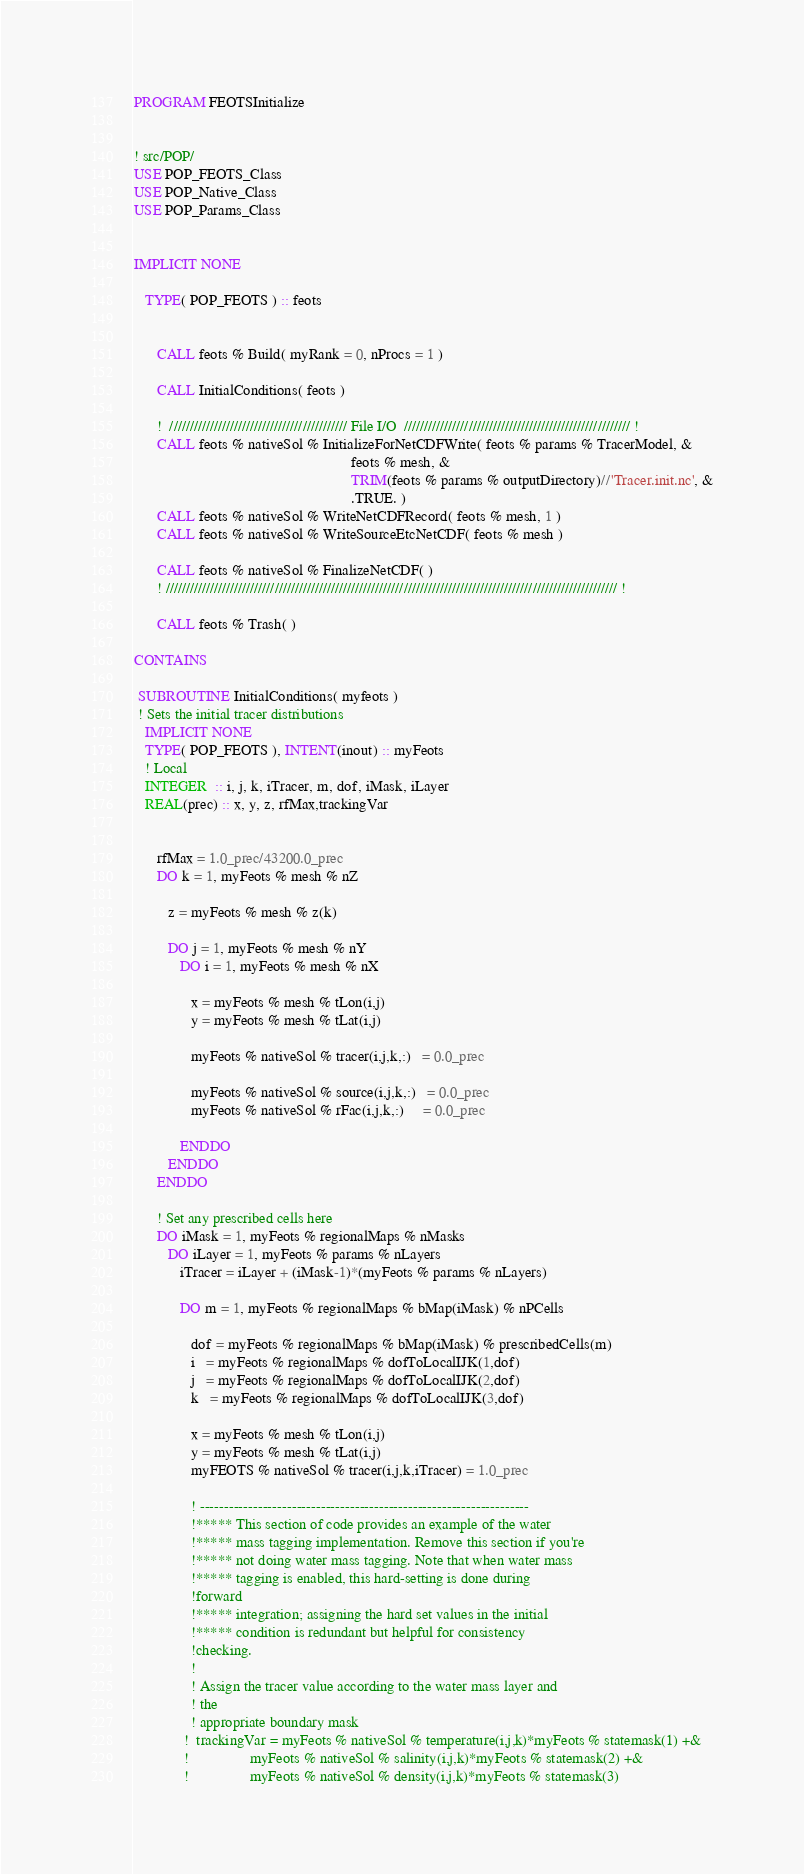<code> <loc_0><loc_0><loc_500><loc_500><_FORTRAN_>PROGRAM FEOTSInitialize


! src/POP/
USE POP_FEOTS_Class
USE POP_Native_Class
USE POP_Params_Class


IMPLICIT NONE

   TYPE( POP_FEOTS ) :: feots


      CALL feots % Build( myRank = 0, nProcs = 1 )

      CALL InitialConditions( feots )

      !  //////////////////////////////////////////// File I/O  //////////////////////////////////////////////////////// !
      CALL feots % nativeSol % InitializeForNetCDFWrite( feots % params % TracerModel, &
                                                         feots % mesh, &
                                                         TRIM(feots % params % outputDirectory)//'Tracer.init.nc', &
                                                         .TRUE. )
      CALL feots % nativeSol % WriteNetCDFRecord( feots % mesh, 1 )
      CALL feots % nativeSol % WriteSourceEtcNetCDF( feots % mesh )

      CALL feots % nativeSol % FinalizeNetCDF( )
      ! //////////////////////////////////////////////////////////////////////////////////////////////////////////////// !

      CALL feots % Trash( )

CONTAINS

 SUBROUTINE InitialConditions( myfeots )
 ! Sets the initial tracer distributions
   IMPLICIT NONE
   TYPE( POP_FEOTS ), INTENT(inout) :: myFeots
   ! Local
   INTEGER  :: i, j, k, iTracer, m, dof, iMask, iLayer
   REAL(prec) :: x, y, z, rfMax,trackingVar


      rfMax = 1.0_prec/43200.0_prec
      DO k = 1, myFeots % mesh % nZ

         z = myFeots % mesh % z(k)

         DO j = 1, myFeots % mesh % nY
            DO i = 1, myFeots % mesh % nX

               x = myFeots % mesh % tLon(i,j)
               y = myFeots % mesh % tLat(i,j)

               myFeots % nativeSol % tracer(i,j,k,:)   = 0.0_prec

               myFeots % nativeSol % source(i,j,k,:)   = 0.0_prec 
               myFeots % nativeSol % rFac(i,j,k,:)     = 0.0_prec 

            ENDDO
         ENDDO
      ENDDO

      ! Set any prescribed cells here
      DO iMask = 1, myFeots % regionalMaps % nMasks
         DO iLayer = 1, myFeots % params % nLayers
            iTracer = iLayer + (iMask-1)*(myFeots % params % nLayers)

            DO m = 1, myFeots % regionalMaps % bMap(iMask) % nPCells

               dof = myFeots % regionalMaps % bMap(iMask) % prescribedCells(m)
               i   = myFeots % regionalMaps % dofToLocalIJK(1,dof)
               j   = myFeots % regionalMaps % dofToLocalIJK(2,dof)
               k   = myFeots % regionalMaps % dofToLocalIJK(3,dof)

               x = myFeots % mesh % tLon(i,j)
               y = myFeots % mesh % tLat(i,j)
               myFEOTS % nativeSol % tracer(i,j,k,iTracer) = 1.0_prec

               ! --------------------------------------------------------------------
               !***** This section of code provides an example of the water
               !***** mass tagging implementation. Remove this section if you're
               !***** not doing water mass tagging. Note that when water mass
               !***** tagging is enabled, this hard-setting is done during
               !forward
               !***** integration; assigning the hard set values in the initial
               !***** condition is redundant but helpful for consistency
               !checking.
               !
               ! Assign the tracer value according to the water mass layer and
               ! the
               ! appropriate boundary mask
             !  trackingVar = myFeots % nativeSol % temperature(i,j,k)*myFeots % statemask(1) +&
             !                myFeots % nativeSol % salinity(i,j,k)*myFeots % statemask(2) +&
             !                myFeots % nativeSol % density(i,j,k)*myFeots % statemask(3)
</code> 